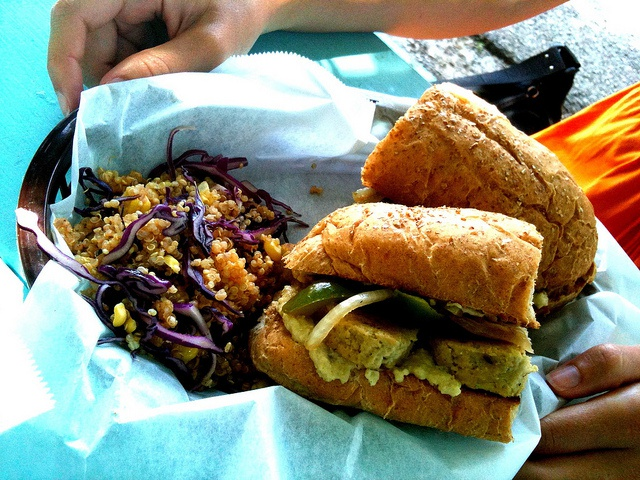Describe the objects in this image and their specific colors. I can see bowl in cyan, black, white, maroon, and olive tones, sandwich in cyan, maroon, olive, and black tones, and people in cyan, gray, tan, and black tones in this image. 